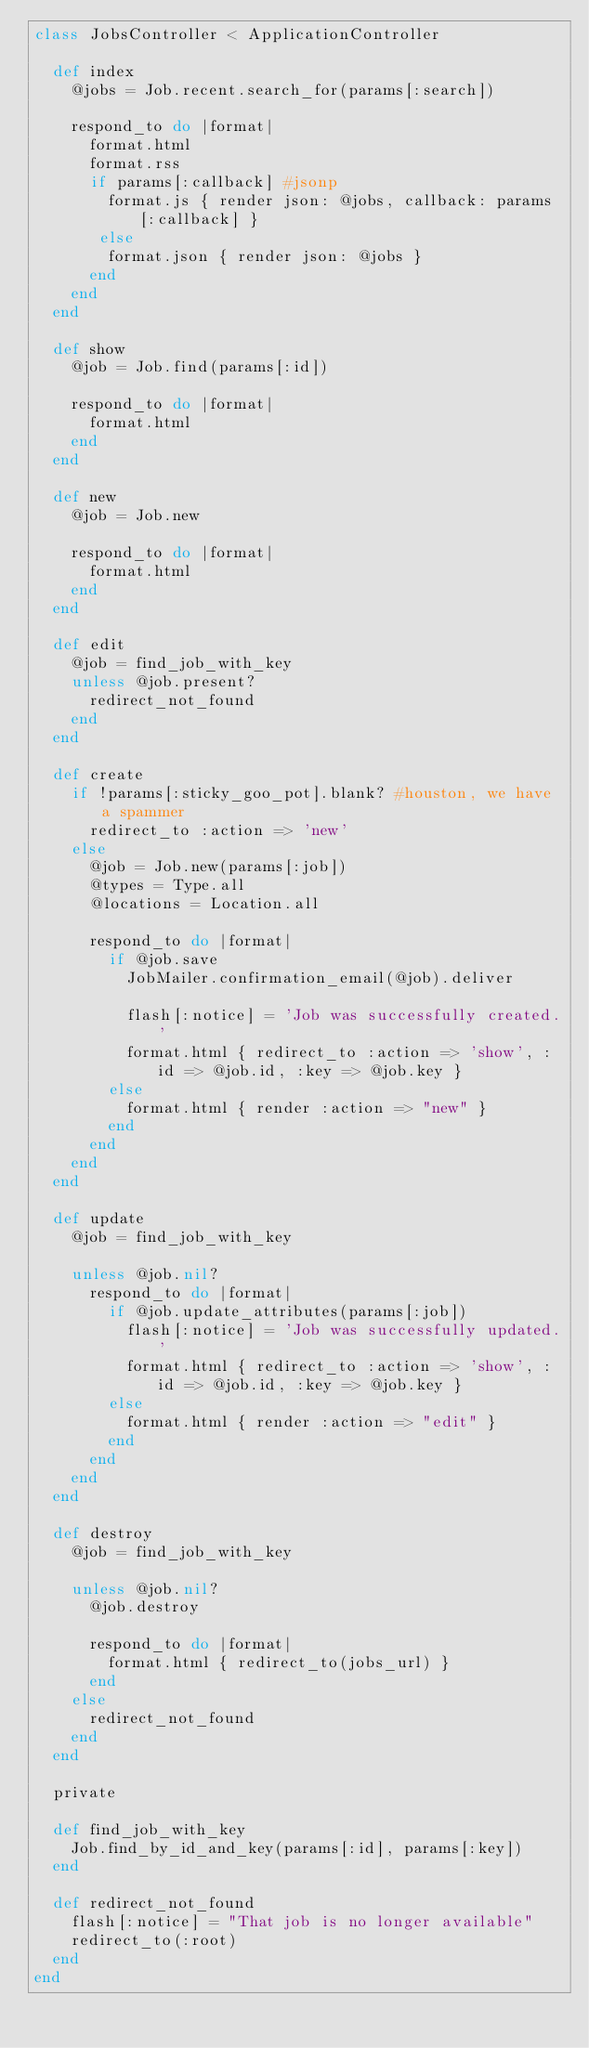<code> <loc_0><loc_0><loc_500><loc_500><_Ruby_>class JobsController < ApplicationController

	def index
		@jobs = Job.recent.search_for(params[:search])

		respond_to do |format|
			format.html
			format.rss
			if params[:callback] #jsonp
     		format.js { render json: @jobs, callback: params[:callback] }
		   else
		   	format.json { render json: @jobs }
		  end
		end
	end

	def show
		@job = Job.find(params[:id])

		respond_to do |format|
			format.html
		end
	end

	def new
		@job = Job.new

		respond_to do |format|
			format.html
		end
	end

	def edit
		@job = find_job_with_key
		unless @job.present?
			redirect_not_found
		end
	end

	def create
		if !params[:sticky_goo_pot].blank? #houston, we have a spammer
			redirect_to :action => 'new'
		else
			@job = Job.new(params[:job])
			@types = Type.all
			@locations = Location.all

			respond_to do |format|
				if @job.save
					JobMailer.confirmation_email(@job).deliver

					flash[:notice] = 'Job was successfully created.'
					format.html { redirect_to :action => 'show', :id => @job.id, :key => @job.key }
				else
					format.html { render :action => "new" }
				end
			end
		end
	end

	def update
		@job = find_job_with_key

		unless @job.nil?
			respond_to do |format|
				if @job.update_attributes(params[:job])
					flash[:notice] = 'Job was successfully updated.'
					format.html { redirect_to :action => 'show', :id => @job.id, :key => @job.key }
				else
					format.html { render :action => "edit" }
				end
			end
		end
	end

	def destroy
		@job = find_job_with_key

		unless @job.nil?
			@job.destroy

			respond_to do |format|
				format.html { redirect_to(jobs_url) }
			end
		else
			redirect_not_found
		end
	end

	private

	def find_job_with_key
		Job.find_by_id_and_key(params[:id], params[:key])
	end

	def redirect_not_found
		flash[:notice] = "That job is no longer available"
		redirect_to(:root)
	end
end
</code> 